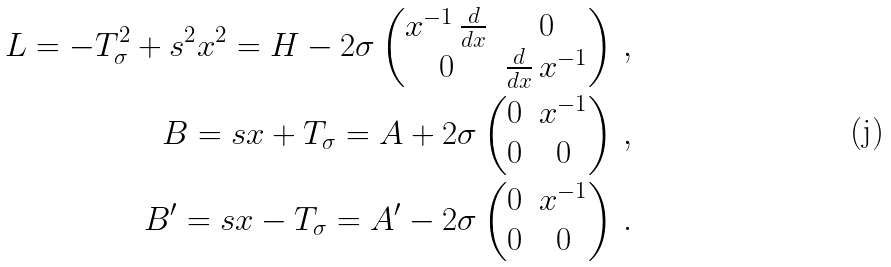<formula> <loc_0><loc_0><loc_500><loc_500>L = - T _ { \sigma } ^ { 2 } + s ^ { 2 } x ^ { 2 } = H - 2 \sigma \begin{pmatrix} x ^ { - 1 } \, \frac { d } { d x } & 0 \\ 0 & \frac { d } { d x } \, x ^ { - 1 } \end{pmatrix} \, , \\ B = s x + T _ { \sigma } = A + 2 \sigma \begin{pmatrix} 0 & x ^ { - 1 } \\ 0 & 0 \end{pmatrix} \, , \\ B ^ { \prime } = s x - T _ { \sigma } = A ^ { \prime } - 2 \sigma \begin{pmatrix} 0 & x ^ { - 1 } \\ 0 & 0 \end{pmatrix} \, .</formula> 